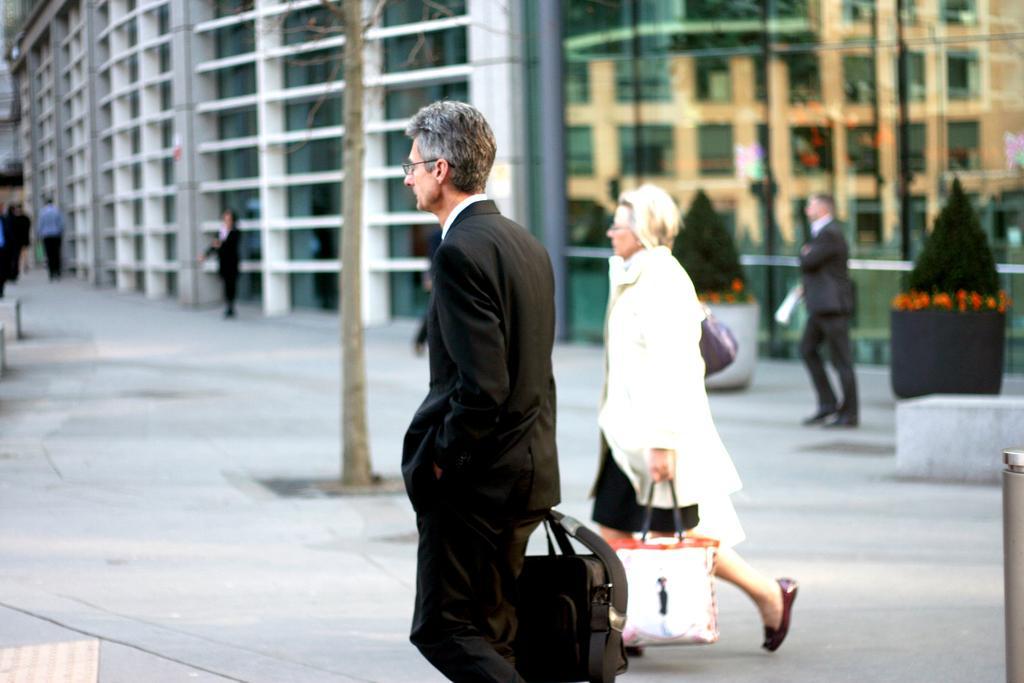Could you give a brief overview of what you see in this image? A man wearing a black suit holding a bag and walking. Another lady wearing a white dress is holding a bag and walking. In the background we can see building, tree, many persons. 